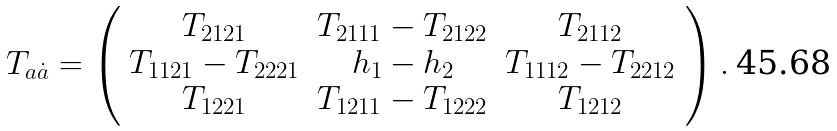Convert formula to latex. <formula><loc_0><loc_0><loc_500><loc_500>T _ { a \dot { a } } = \left ( \begin{array} { c c c } T _ { 2 1 2 1 } & T _ { 2 1 1 1 } - T _ { 2 1 2 2 } & T _ { 2 1 1 2 } \\ T _ { 1 1 2 1 } - T _ { 2 2 2 1 } & h _ { 1 } - h _ { 2 } & T _ { 1 1 1 2 } - T _ { 2 2 1 2 } \\ T _ { 1 2 2 1 } & T _ { 1 2 1 1 } - T _ { 1 2 2 2 } & T _ { 1 2 1 2 } \end{array} \right ) .</formula> 